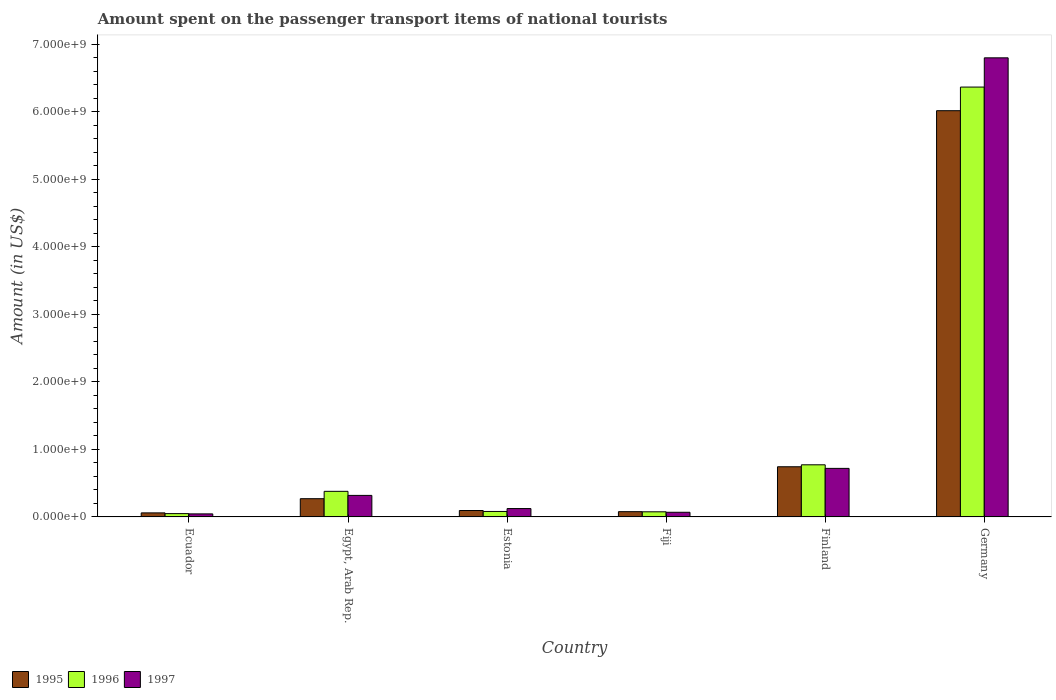How many different coloured bars are there?
Offer a very short reply. 3. How many groups of bars are there?
Ensure brevity in your answer.  6. Are the number of bars per tick equal to the number of legend labels?
Keep it short and to the point. Yes. How many bars are there on the 6th tick from the right?
Your response must be concise. 3. What is the amount spent on the passenger transport items of national tourists in 1996 in Egypt, Arab Rep.?
Your response must be concise. 3.79e+08. Across all countries, what is the maximum amount spent on the passenger transport items of national tourists in 1996?
Give a very brief answer. 6.37e+09. Across all countries, what is the minimum amount spent on the passenger transport items of national tourists in 1995?
Keep it short and to the point. 6.00e+07. In which country was the amount spent on the passenger transport items of national tourists in 1996 maximum?
Keep it short and to the point. Germany. In which country was the amount spent on the passenger transport items of national tourists in 1995 minimum?
Keep it short and to the point. Ecuador. What is the total amount spent on the passenger transport items of national tourists in 1995 in the graph?
Offer a very short reply. 7.26e+09. What is the difference between the amount spent on the passenger transport items of national tourists in 1997 in Fiji and that in Germany?
Ensure brevity in your answer.  -6.73e+09. What is the difference between the amount spent on the passenger transport items of national tourists in 1995 in Finland and the amount spent on the passenger transport items of national tourists in 1997 in Ecuador?
Ensure brevity in your answer.  6.98e+08. What is the average amount spent on the passenger transport items of national tourists in 1997 per country?
Your answer should be compact. 1.35e+09. What is the difference between the amount spent on the passenger transport items of national tourists of/in 1997 and amount spent on the passenger transport items of national tourists of/in 1995 in Ecuador?
Ensure brevity in your answer.  -1.50e+07. What is the ratio of the amount spent on the passenger transport items of national tourists in 1996 in Fiji to that in Finland?
Offer a very short reply. 0.1. Is the amount spent on the passenger transport items of national tourists in 1995 in Egypt, Arab Rep. less than that in Finland?
Your answer should be compact. Yes. What is the difference between the highest and the second highest amount spent on the passenger transport items of national tourists in 1995?
Keep it short and to the point. 5.75e+09. What is the difference between the highest and the lowest amount spent on the passenger transport items of national tourists in 1997?
Make the answer very short. 6.75e+09. What does the 2nd bar from the right in Fiji represents?
Ensure brevity in your answer.  1996. How many bars are there?
Your answer should be very brief. 18. Are all the bars in the graph horizontal?
Make the answer very short. No. How many countries are there in the graph?
Your answer should be compact. 6. Does the graph contain grids?
Offer a terse response. No. How many legend labels are there?
Your response must be concise. 3. How are the legend labels stacked?
Offer a terse response. Horizontal. What is the title of the graph?
Your response must be concise. Amount spent on the passenger transport items of national tourists. What is the label or title of the X-axis?
Give a very brief answer. Country. What is the label or title of the Y-axis?
Provide a succinct answer. Amount (in US$). What is the Amount (in US$) in 1995 in Ecuador?
Your answer should be compact. 6.00e+07. What is the Amount (in US$) in 1996 in Ecuador?
Keep it short and to the point. 4.90e+07. What is the Amount (in US$) of 1997 in Ecuador?
Make the answer very short. 4.50e+07. What is the Amount (in US$) of 1995 in Egypt, Arab Rep.?
Your response must be concise. 2.70e+08. What is the Amount (in US$) of 1996 in Egypt, Arab Rep.?
Provide a succinct answer. 3.79e+08. What is the Amount (in US$) of 1997 in Egypt, Arab Rep.?
Give a very brief answer. 3.19e+08. What is the Amount (in US$) of 1995 in Estonia?
Provide a succinct answer. 9.50e+07. What is the Amount (in US$) of 1996 in Estonia?
Your response must be concise. 8.10e+07. What is the Amount (in US$) of 1997 in Estonia?
Make the answer very short. 1.24e+08. What is the Amount (in US$) of 1995 in Fiji?
Your answer should be very brief. 7.80e+07. What is the Amount (in US$) in 1996 in Fiji?
Ensure brevity in your answer.  7.60e+07. What is the Amount (in US$) of 1997 in Fiji?
Make the answer very short. 6.90e+07. What is the Amount (in US$) of 1995 in Finland?
Your response must be concise. 7.43e+08. What is the Amount (in US$) of 1996 in Finland?
Keep it short and to the point. 7.72e+08. What is the Amount (in US$) in 1997 in Finland?
Your answer should be compact. 7.19e+08. What is the Amount (in US$) of 1995 in Germany?
Ensure brevity in your answer.  6.02e+09. What is the Amount (in US$) in 1996 in Germany?
Your response must be concise. 6.37e+09. What is the Amount (in US$) of 1997 in Germany?
Your response must be concise. 6.80e+09. Across all countries, what is the maximum Amount (in US$) of 1995?
Your response must be concise. 6.02e+09. Across all countries, what is the maximum Amount (in US$) in 1996?
Give a very brief answer. 6.37e+09. Across all countries, what is the maximum Amount (in US$) in 1997?
Provide a succinct answer. 6.80e+09. Across all countries, what is the minimum Amount (in US$) in 1995?
Offer a terse response. 6.00e+07. Across all countries, what is the minimum Amount (in US$) of 1996?
Ensure brevity in your answer.  4.90e+07. Across all countries, what is the minimum Amount (in US$) in 1997?
Give a very brief answer. 4.50e+07. What is the total Amount (in US$) in 1995 in the graph?
Your response must be concise. 7.26e+09. What is the total Amount (in US$) in 1996 in the graph?
Your answer should be very brief. 7.72e+09. What is the total Amount (in US$) of 1997 in the graph?
Give a very brief answer. 8.07e+09. What is the difference between the Amount (in US$) of 1995 in Ecuador and that in Egypt, Arab Rep.?
Your answer should be very brief. -2.10e+08. What is the difference between the Amount (in US$) in 1996 in Ecuador and that in Egypt, Arab Rep.?
Keep it short and to the point. -3.30e+08. What is the difference between the Amount (in US$) of 1997 in Ecuador and that in Egypt, Arab Rep.?
Your answer should be very brief. -2.74e+08. What is the difference between the Amount (in US$) of 1995 in Ecuador and that in Estonia?
Provide a succinct answer. -3.50e+07. What is the difference between the Amount (in US$) of 1996 in Ecuador and that in Estonia?
Provide a short and direct response. -3.20e+07. What is the difference between the Amount (in US$) in 1997 in Ecuador and that in Estonia?
Offer a very short reply. -7.90e+07. What is the difference between the Amount (in US$) of 1995 in Ecuador and that in Fiji?
Offer a terse response. -1.80e+07. What is the difference between the Amount (in US$) of 1996 in Ecuador and that in Fiji?
Offer a very short reply. -2.70e+07. What is the difference between the Amount (in US$) of 1997 in Ecuador and that in Fiji?
Your answer should be compact. -2.40e+07. What is the difference between the Amount (in US$) in 1995 in Ecuador and that in Finland?
Your response must be concise. -6.83e+08. What is the difference between the Amount (in US$) of 1996 in Ecuador and that in Finland?
Ensure brevity in your answer.  -7.23e+08. What is the difference between the Amount (in US$) of 1997 in Ecuador and that in Finland?
Your answer should be very brief. -6.74e+08. What is the difference between the Amount (in US$) of 1995 in Ecuador and that in Germany?
Your answer should be compact. -5.96e+09. What is the difference between the Amount (in US$) of 1996 in Ecuador and that in Germany?
Ensure brevity in your answer.  -6.32e+09. What is the difference between the Amount (in US$) in 1997 in Ecuador and that in Germany?
Keep it short and to the point. -6.75e+09. What is the difference between the Amount (in US$) in 1995 in Egypt, Arab Rep. and that in Estonia?
Make the answer very short. 1.75e+08. What is the difference between the Amount (in US$) in 1996 in Egypt, Arab Rep. and that in Estonia?
Keep it short and to the point. 2.98e+08. What is the difference between the Amount (in US$) of 1997 in Egypt, Arab Rep. and that in Estonia?
Offer a terse response. 1.95e+08. What is the difference between the Amount (in US$) in 1995 in Egypt, Arab Rep. and that in Fiji?
Provide a succinct answer. 1.92e+08. What is the difference between the Amount (in US$) in 1996 in Egypt, Arab Rep. and that in Fiji?
Offer a very short reply. 3.03e+08. What is the difference between the Amount (in US$) of 1997 in Egypt, Arab Rep. and that in Fiji?
Your response must be concise. 2.50e+08. What is the difference between the Amount (in US$) in 1995 in Egypt, Arab Rep. and that in Finland?
Ensure brevity in your answer.  -4.73e+08. What is the difference between the Amount (in US$) in 1996 in Egypt, Arab Rep. and that in Finland?
Offer a very short reply. -3.93e+08. What is the difference between the Amount (in US$) in 1997 in Egypt, Arab Rep. and that in Finland?
Keep it short and to the point. -4.00e+08. What is the difference between the Amount (in US$) in 1995 in Egypt, Arab Rep. and that in Germany?
Your answer should be compact. -5.75e+09. What is the difference between the Amount (in US$) in 1996 in Egypt, Arab Rep. and that in Germany?
Give a very brief answer. -5.99e+09. What is the difference between the Amount (in US$) in 1997 in Egypt, Arab Rep. and that in Germany?
Offer a terse response. -6.48e+09. What is the difference between the Amount (in US$) of 1995 in Estonia and that in Fiji?
Provide a short and direct response. 1.70e+07. What is the difference between the Amount (in US$) of 1996 in Estonia and that in Fiji?
Offer a terse response. 5.00e+06. What is the difference between the Amount (in US$) of 1997 in Estonia and that in Fiji?
Provide a succinct answer. 5.50e+07. What is the difference between the Amount (in US$) of 1995 in Estonia and that in Finland?
Ensure brevity in your answer.  -6.48e+08. What is the difference between the Amount (in US$) of 1996 in Estonia and that in Finland?
Make the answer very short. -6.91e+08. What is the difference between the Amount (in US$) of 1997 in Estonia and that in Finland?
Offer a terse response. -5.95e+08. What is the difference between the Amount (in US$) in 1995 in Estonia and that in Germany?
Make the answer very short. -5.92e+09. What is the difference between the Amount (in US$) in 1996 in Estonia and that in Germany?
Offer a very short reply. -6.28e+09. What is the difference between the Amount (in US$) in 1997 in Estonia and that in Germany?
Provide a short and direct response. -6.68e+09. What is the difference between the Amount (in US$) of 1995 in Fiji and that in Finland?
Give a very brief answer. -6.65e+08. What is the difference between the Amount (in US$) of 1996 in Fiji and that in Finland?
Your answer should be compact. -6.96e+08. What is the difference between the Amount (in US$) in 1997 in Fiji and that in Finland?
Provide a succinct answer. -6.50e+08. What is the difference between the Amount (in US$) in 1995 in Fiji and that in Germany?
Your response must be concise. -5.94e+09. What is the difference between the Amount (in US$) of 1996 in Fiji and that in Germany?
Keep it short and to the point. -6.29e+09. What is the difference between the Amount (in US$) of 1997 in Fiji and that in Germany?
Ensure brevity in your answer.  -6.73e+09. What is the difference between the Amount (in US$) of 1995 in Finland and that in Germany?
Your response must be concise. -5.27e+09. What is the difference between the Amount (in US$) of 1996 in Finland and that in Germany?
Keep it short and to the point. -5.59e+09. What is the difference between the Amount (in US$) in 1997 in Finland and that in Germany?
Your response must be concise. -6.08e+09. What is the difference between the Amount (in US$) of 1995 in Ecuador and the Amount (in US$) of 1996 in Egypt, Arab Rep.?
Your response must be concise. -3.19e+08. What is the difference between the Amount (in US$) of 1995 in Ecuador and the Amount (in US$) of 1997 in Egypt, Arab Rep.?
Provide a succinct answer. -2.59e+08. What is the difference between the Amount (in US$) of 1996 in Ecuador and the Amount (in US$) of 1997 in Egypt, Arab Rep.?
Give a very brief answer. -2.70e+08. What is the difference between the Amount (in US$) in 1995 in Ecuador and the Amount (in US$) in 1996 in Estonia?
Your answer should be compact. -2.10e+07. What is the difference between the Amount (in US$) of 1995 in Ecuador and the Amount (in US$) of 1997 in Estonia?
Keep it short and to the point. -6.40e+07. What is the difference between the Amount (in US$) in 1996 in Ecuador and the Amount (in US$) in 1997 in Estonia?
Provide a succinct answer. -7.50e+07. What is the difference between the Amount (in US$) in 1995 in Ecuador and the Amount (in US$) in 1996 in Fiji?
Your answer should be compact. -1.60e+07. What is the difference between the Amount (in US$) of 1995 in Ecuador and the Amount (in US$) of 1997 in Fiji?
Make the answer very short. -9.00e+06. What is the difference between the Amount (in US$) of 1996 in Ecuador and the Amount (in US$) of 1997 in Fiji?
Make the answer very short. -2.00e+07. What is the difference between the Amount (in US$) in 1995 in Ecuador and the Amount (in US$) in 1996 in Finland?
Provide a short and direct response. -7.12e+08. What is the difference between the Amount (in US$) of 1995 in Ecuador and the Amount (in US$) of 1997 in Finland?
Ensure brevity in your answer.  -6.59e+08. What is the difference between the Amount (in US$) in 1996 in Ecuador and the Amount (in US$) in 1997 in Finland?
Provide a succinct answer. -6.70e+08. What is the difference between the Amount (in US$) of 1995 in Ecuador and the Amount (in US$) of 1996 in Germany?
Provide a short and direct response. -6.31e+09. What is the difference between the Amount (in US$) in 1995 in Ecuador and the Amount (in US$) in 1997 in Germany?
Your response must be concise. -6.74e+09. What is the difference between the Amount (in US$) of 1996 in Ecuador and the Amount (in US$) of 1997 in Germany?
Your answer should be very brief. -6.75e+09. What is the difference between the Amount (in US$) in 1995 in Egypt, Arab Rep. and the Amount (in US$) in 1996 in Estonia?
Give a very brief answer. 1.89e+08. What is the difference between the Amount (in US$) of 1995 in Egypt, Arab Rep. and the Amount (in US$) of 1997 in Estonia?
Offer a very short reply. 1.46e+08. What is the difference between the Amount (in US$) in 1996 in Egypt, Arab Rep. and the Amount (in US$) in 1997 in Estonia?
Make the answer very short. 2.55e+08. What is the difference between the Amount (in US$) of 1995 in Egypt, Arab Rep. and the Amount (in US$) of 1996 in Fiji?
Offer a terse response. 1.94e+08. What is the difference between the Amount (in US$) of 1995 in Egypt, Arab Rep. and the Amount (in US$) of 1997 in Fiji?
Your answer should be compact. 2.01e+08. What is the difference between the Amount (in US$) of 1996 in Egypt, Arab Rep. and the Amount (in US$) of 1997 in Fiji?
Offer a very short reply. 3.10e+08. What is the difference between the Amount (in US$) in 1995 in Egypt, Arab Rep. and the Amount (in US$) in 1996 in Finland?
Make the answer very short. -5.02e+08. What is the difference between the Amount (in US$) of 1995 in Egypt, Arab Rep. and the Amount (in US$) of 1997 in Finland?
Your answer should be very brief. -4.49e+08. What is the difference between the Amount (in US$) in 1996 in Egypt, Arab Rep. and the Amount (in US$) in 1997 in Finland?
Make the answer very short. -3.40e+08. What is the difference between the Amount (in US$) of 1995 in Egypt, Arab Rep. and the Amount (in US$) of 1996 in Germany?
Your answer should be compact. -6.10e+09. What is the difference between the Amount (in US$) of 1995 in Egypt, Arab Rep. and the Amount (in US$) of 1997 in Germany?
Offer a very short reply. -6.53e+09. What is the difference between the Amount (in US$) of 1996 in Egypt, Arab Rep. and the Amount (in US$) of 1997 in Germany?
Your answer should be compact. -6.42e+09. What is the difference between the Amount (in US$) of 1995 in Estonia and the Amount (in US$) of 1996 in Fiji?
Offer a very short reply. 1.90e+07. What is the difference between the Amount (in US$) in 1995 in Estonia and the Amount (in US$) in 1997 in Fiji?
Your response must be concise. 2.60e+07. What is the difference between the Amount (in US$) of 1996 in Estonia and the Amount (in US$) of 1997 in Fiji?
Offer a very short reply. 1.20e+07. What is the difference between the Amount (in US$) in 1995 in Estonia and the Amount (in US$) in 1996 in Finland?
Provide a short and direct response. -6.77e+08. What is the difference between the Amount (in US$) in 1995 in Estonia and the Amount (in US$) in 1997 in Finland?
Give a very brief answer. -6.24e+08. What is the difference between the Amount (in US$) in 1996 in Estonia and the Amount (in US$) in 1997 in Finland?
Offer a very short reply. -6.38e+08. What is the difference between the Amount (in US$) in 1995 in Estonia and the Amount (in US$) in 1996 in Germany?
Ensure brevity in your answer.  -6.27e+09. What is the difference between the Amount (in US$) in 1995 in Estonia and the Amount (in US$) in 1997 in Germany?
Offer a terse response. -6.70e+09. What is the difference between the Amount (in US$) of 1996 in Estonia and the Amount (in US$) of 1997 in Germany?
Give a very brief answer. -6.72e+09. What is the difference between the Amount (in US$) in 1995 in Fiji and the Amount (in US$) in 1996 in Finland?
Your response must be concise. -6.94e+08. What is the difference between the Amount (in US$) of 1995 in Fiji and the Amount (in US$) of 1997 in Finland?
Your answer should be compact. -6.41e+08. What is the difference between the Amount (in US$) of 1996 in Fiji and the Amount (in US$) of 1997 in Finland?
Ensure brevity in your answer.  -6.43e+08. What is the difference between the Amount (in US$) in 1995 in Fiji and the Amount (in US$) in 1996 in Germany?
Offer a terse response. -6.29e+09. What is the difference between the Amount (in US$) in 1995 in Fiji and the Amount (in US$) in 1997 in Germany?
Provide a short and direct response. -6.72e+09. What is the difference between the Amount (in US$) of 1996 in Fiji and the Amount (in US$) of 1997 in Germany?
Offer a very short reply. -6.72e+09. What is the difference between the Amount (in US$) of 1995 in Finland and the Amount (in US$) of 1996 in Germany?
Your response must be concise. -5.62e+09. What is the difference between the Amount (in US$) in 1995 in Finland and the Amount (in US$) in 1997 in Germany?
Provide a succinct answer. -6.06e+09. What is the difference between the Amount (in US$) in 1996 in Finland and the Amount (in US$) in 1997 in Germany?
Your answer should be very brief. -6.03e+09. What is the average Amount (in US$) in 1995 per country?
Your response must be concise. 1.21e+09. What is the average Amount (in US$) in 1996 per country?
Your answer should be compact. 1.29e+09. What is the average Amount (in US$) of 1997 per country?
Offer a very short reply. 1.35e+09. What is the difference between the Amount (in US$) of 1995 and Amount (in US$) of 1996 in Ecuador?
Offer a terse response. 1.10e+07. What is the difference between the Amount (in US$) of 1995 and Amount (in US$) of 1997 in Ecuador?
Your answer should be compact. 1.50e+07. What is the difference between the Amount (in US$) in 1995 and Amount (in US$) in 1996 in Egypt, Arab Rep.?
Make the answer very short. -1.09e+08. What is the difference between the Amount (in US$) in 1995 and Amount (in US$) in 1997 in Egypt, Arab Rep.?
Offer a terse response. -4.88e+07. What is the difference between the Amount (in US$) of 1996 and Amount (in US$) of 1997 in Egypt, Arab Rep.?
Offer a very short reply. 6.02e+07. What is the difference between the Amount (in US$) of 1995 and Amount (in US$) of 1996 in Estonia?
Ensure brevity in your answer.  1.40e+07. What is the difference between the Amount (in US$) in 1995 and Amount (in US$) in 1997 in Estonia?
Make the answer very short. -2.90e+07. What is the difference between the Amount (in US$) in 1996 and Amount (in US$) in 1997 in Estonia?
Your answer should be very brief. -4.30e+07. What is the difference between the Amount (in US$) in 1995 and Amount (in US$) in 1996 in Fiji?
Provide a short and direct response. 2.00e+06. What is the difference between the Amount (in US$) in 1995 and Amount (in US$) in 1997 in Fiji?
Offer a terse response. 9.00e+06. What is the difference between the Amount (in US$) of 1995 and Amount (in US$) of 1996 in Finland?
Give a very brief answer. -2.90e+07. What is the difference between the Amount (in US$) in 1995 and Amount (in US$) in 1997 in Finland?
Your response must be concise. 2.40e+07. What is the difference between the Amount (in US$) of 1996 and Amount (in US$) of 1997 in Finland?
Give a very brief answer. 5.30e+07. What is the difference between the Amount (in US$) of 1995 and Amount (in US$) of 1996 in Germany?
Your answer should be compact. -3.50e+08. What is the difference between the Amount (in US$) in 1995 and Amount (in US$) in 1997 in Germany?
Your answer should be compact. -7.83e+08. What is the difference between the Amount (in US$) of 1996 and Amount (in US$) of 1997 in Germany?
Provide a succinct answer. -4.33e+08. What is the ratio of the Amount (in US$) of 1995 in Ecuador to that in Egypt, Arab Rep.?
Keep it short and to the point. 0.22. What is the ratio of the Amount (in US$) in 1996 in Ecuador to that in Egypt, Arab Rep.?
Offer a very short reply. 0.13. What is the ratio of the Amount (in US$) of 1997 in Ecuador to that in Egypt, Arab Rep.?
Your answer should be very brief. 0.14. What is the ratio of the Amount (in US$) in 1995 in Ecuador to that in Estonia?
Give a very brief answer. 0.63. What is the ratio of the Amount (in US$) of 1996 in Ecuador to that in Estonia?
Your answer should be very brief. 0.6. What is the ratio of the Amount (in US$) in 1997 in Ecuador to that in Estonia?
Your answer should be compact. 0.36. What is the ratio of the Amount (in US$) in 1995 in Ecuador to that in Fiji?
Provide a succinct answer. 0.77. What is the ratio of the Amount (in US$) of 1996 in Ecuador to that in Fiji?
Give a very brief answer. 0.64. What is the ratio of the Amount (in US$) of 1997 in Ecuador to that in Fiji?
Offer a very short reply. 0.65. What is the ratio of the Amount (in US$) of 1995 in Ecuador to that in Finland?
Offer a terse response. 0.08. What is the ratio of the Amount (in US$) in 1996 in Ecuador to that in Finland?
Keep it short and to the point. 0.06. What is the ratio of the Amount (in US$) of 1997 in Ecuador to that in Finland?
Give a very brief answer. 0.06. What is the ratio of the Amount (in US$) in 1995 in Ecuador to that in Germany?
Make the answer very short. 0.01. What is the ratio of the Amount (in US$) in 1996 in Ecuador to that in Germany?
Make the answer very short. 0.01. What is the ratio of the Amount (in US$) of 1997 in Ecuador to that in Germany?
Offer a terse response. 0.01. What is the ratio of the Amount (in US$) in 1995 in Egypt, Arab Rep. to that in Estonia?
Offer a very short reply. 2.84. What is the ratio of the Amount (in US$) in 1996 in Egypt, Arab Rep. to that in Estonia?
Make the answer very short. 4.68. What is the ratio of the Amount (in US$) of 1997 in Egypt, Arab Rep. to that in Estonia?
Offer a very short reply. 2.57. What is the ratio of the Amount (in US$) in 1995 in Egypt, Arab Rep. to that in Fiji?
Provide a succinct answer. 3.46. What is the ratio of the Amount (in US$) of 1996 in Egypt, Arab Rep. to that in Fiji?
Offer a terse response. 4.99. What is the ratio of the Amount (in US$) in 1997 in Egypt, Arab Rep. to that in Fiji?
Keep it short and to the point. 4.62. What is the ratio of the Amount (in US$) of 1995 in Egypt, Arab Rep. to that in Finland?
Keep it short and to the point. 0.36. What is the ratio of the Amount (in US$) of 1996 in Egypt, Arab Rep. to that in Finland?
Ensure brevity in your answer.  0.49. What is the ratio of the Amount (in US$) of 1997 in Egypt, Arab Rep. to that in Finland?
Your answer should be compact. 0.44. What is the ratio of the Amount (in US$) of 1995 in Egypt, Arab Rep. to that in Germany?
Ensure brevity in your answer.  0.04. What is the ratio of the Amount (in US$) in 1996 in Egypt, Arab Rep. to that in Germany?
Offer a terse response. 0.06. What is the ratio of the Amount (in US$) in 1997 in Egypt, Arab Rep. to that in Germany?
Offer a very short reply. 0.05. What is the ratio of the Amount (in US$) of 1995 in Estonia to that in Fiji?
Offer a terse response. 1.22. What is the ratio of the Amount (in US$) of 1996 in Estonia to that in Fiji?
Your response must be concise. 1.07. What is the ratio of the Amount (in US$) in 1997 in Estonia to that in Fiji?
Keep it short and to the point. 1.8. What is the ratio of the Amount (in US$) of 1995 in Estonia to that in Finland?
Keep it short and to the point. 0.13. What is the ratio of the Amount (in US$) of 1996 in Estonia to that in Finland?
Your answer should be compact. 0.1. What is the ratio of the Amount (in US$) in 1997 in Estonia to that in Finland?
Ensure brevity in your answer.  0.17. What is the ratio of the Amount (in US$) of 1995 in Estonia to that in Germany?
Your response must be concise. 0.02. What is the ratio of the Amount (in US$) of 1996 in Estonia to that in Germany?
Offer a very short reply. 0.01. What is the ratio of the Amount (in US$) of 1997 in Estonia to that in Germany?
Keep it short and to the point. 0.02. What is the ratio of the Amount (in US$) of 1995 in Fiji to that in Finland?
Provide a succinct answer. 0.1. What is the ratio of the Amount (in US$) in 1996 in Fiji to that in Finland?
Offer a terse response. 0.1. What is the ratio of the Amount (in US$) of 1997 in Fiji to that in Finland?
Make the answer very short. 0.1. What is the ratio of the Amount (in US$) in 1995 in Fiji to that in Germany?
Give a very brief answer. 0.01. What is the ratio of the Amount (in US$) in 1996 in Fiji to that in Germany?
Ensure brevity in your answer.  0.01. What is the ratio of the Amount (in US$) of 1997 in Fiji to that in Germany?
Give a very brief answer. 0.01. What is the ratio of the Amount (in US$) of 1995 in Finland to that in Germany?
Ensure brevity in your answer.  0.12. What is the ratio of the Amount (in US$) of 1996 in Finland to that in Germany?
Ensure brevity in your answer.  0.12. What is the ratio of the Amount (in US$) of 1997 in Finland to that in Germany?
Your response must be concise. 0.11. What is the difference between the highest and the second highest Amount (in US$) in 1995?
Give a very brief answer. 5.27e+09. What is the difference between the highest and the second highest Amount (in US$) of 1996?
Your response must be concise. 5.59e+09. What is the difference between the highest and the second highest Amount (in US$) of 1997?
Ensure brevity in your answer.  6.08e+09. What is the difference between the highest and the lowest Amount (in US$) of 1995?
Provide a succinct answer. 5.96e+09. What is the difference between the highest and the lowest Amount (in US$) of 1996?
Offer a terse response. 6.32e+09. What is the difference between the highest and the lowest Amount (in US$) of 1997?
Your answer should be compact. 6.75e+09. 